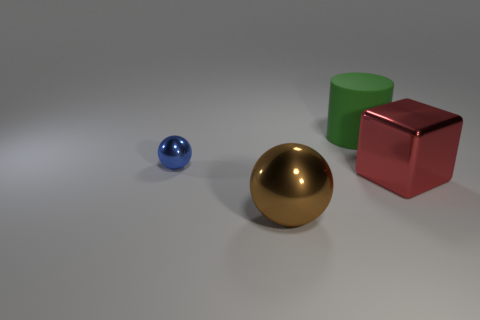How many metal cubes are the same color as the cylinder?
Provide a succinct answer. 0. Are there any small cyan rubber cylinders?
Offer a terse response. No. Does the small thing have the same shape as the large shiny thing that is on the right side of the brown object?
Provide a short and direct response. No. What is the color of the ball right of the sphere to the left of the large metallic thing in front of the red block?
Provide a short and direct response. Brown. There is a brown object; are there any large brown things right of it?
Ensure brevity in your answer.  No. Are there any other purple spheres made of the same material as the big sphere?
Provide a succinct answer. No. What is the color of the metal block?
Provide a short and direct response. Red. Is the shape of the large metallic thing that is right of the large metal sphere the same as  the brown thing?
Provide a succinct answer. No. There is a object that is behind the metallic thing to the left of the ball that is right of the tiny shiny thing; what shape is it?
Ensure brevity in your answer.  Cylinder. What material is the object behind the blue shiny object?
Your response must be concise. Rubber. 